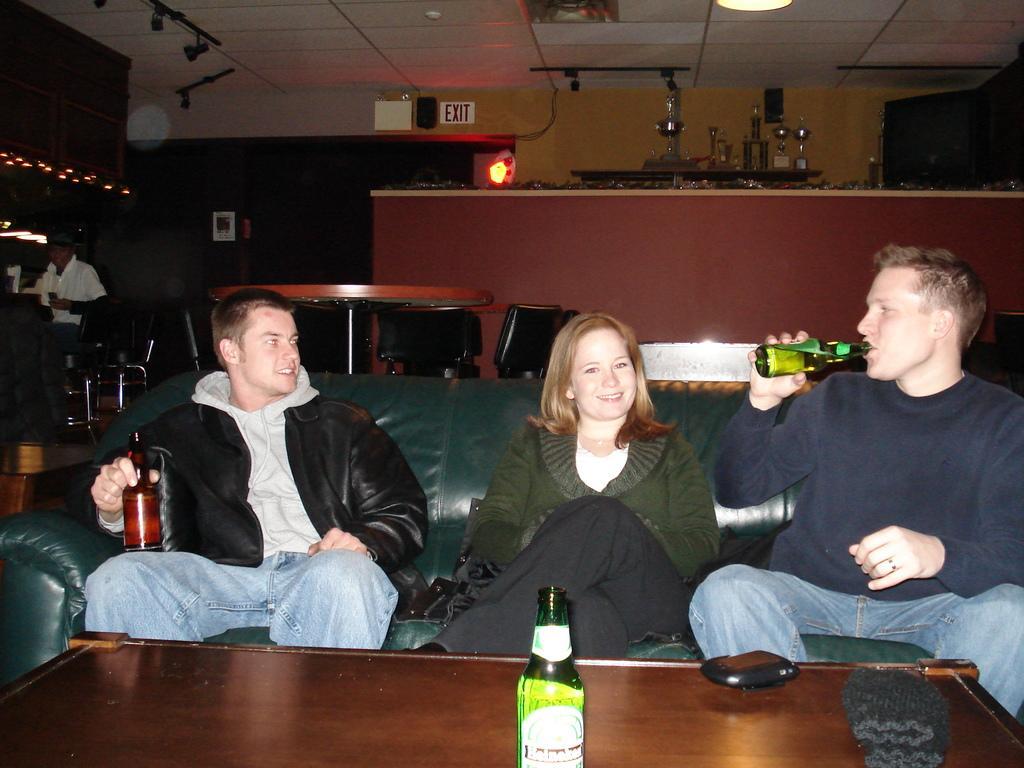Please provide a concise description of this image. In the center of the image there are three people sitting on the sofa before them there is a table and a bottle placed on the table. In the background there are people, a counter and a wall. 